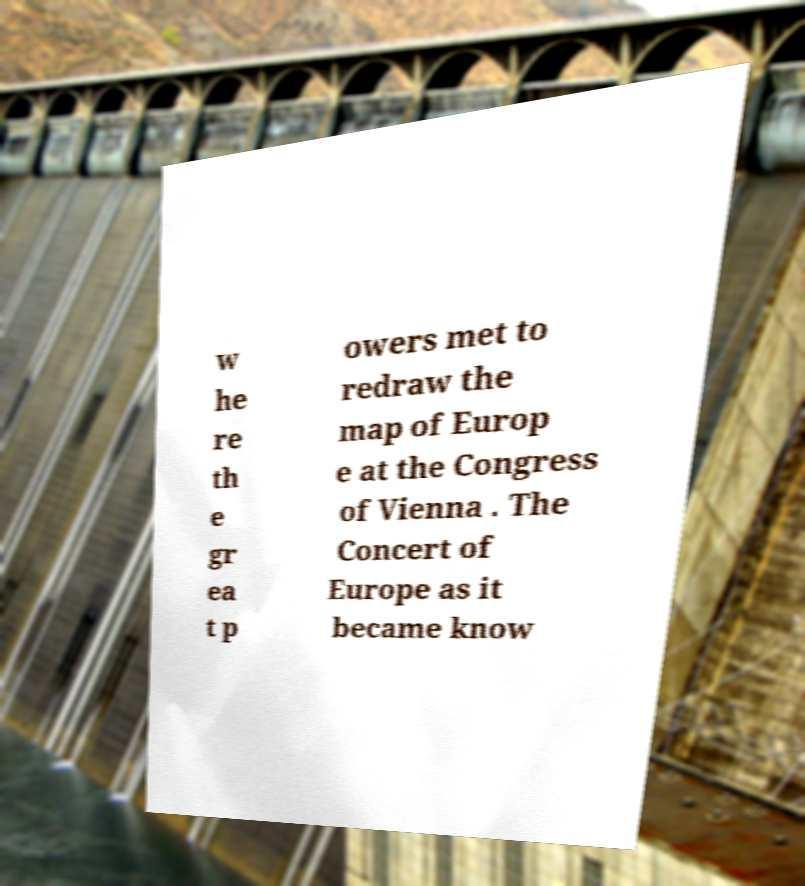Please read and relay the text visible in this image. What does it say? w he re th e gr ea t p owers met to redraw the map of Europ e at the Congress of Vienna . The Concert of Europe as it became know 